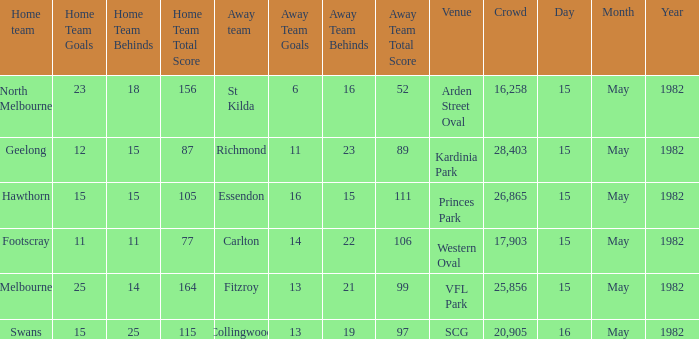19 (97)? Swans. 